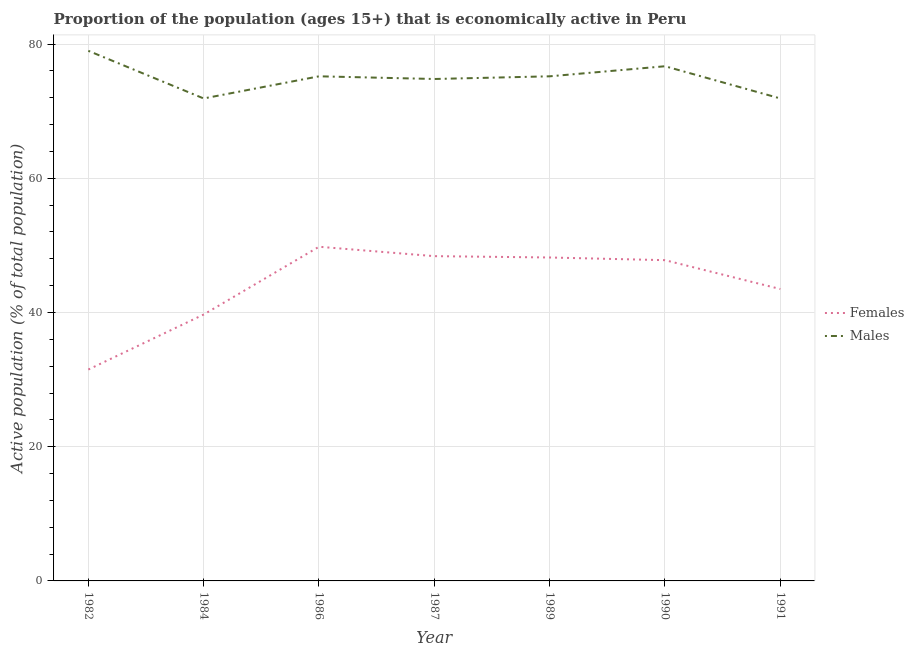How many different coloured lines are there?
Make the answer very short. 2. Is the number of lines equal to the number of legend labels?
Your answer should be very brief. Yes. What is the percentage of economically active male population in 1990?
Provide a short and direct response. 76.7. Across all years, what is the maximum percentage of economically active male population?
Offer a very short reply. 79. Across all years, what is the minimum percentage of economically active female population?
Keep it short and to the point. 31.5. In which year was the percentage of economically active male population minimum?
Your response must be concise. 1984. What is the total percentage of economically active male population in the graph?
Make the answer very short. 524.7. What is the difference between the percentage of economically active female population in 1982 and that in 1984?
Your answer should be very brief. -8.2. What is the difference between the percentage of economically active female population in 1990 and the percentage of economically active male population in 1984?
Offer a very short reply. -24.1. What is the average percentage of economically active female population per year?
Offer a terse response. 44.13. In the year 1987, what is the difference between the percentage of economically active female population and percentage of economically active male population?
Make the answer very short. -26.4. What is the ratio of the percentage of economically active female population in 1984 to that in 1990?
Give a very brief answer. 0.83. What is the difference between the highest and the second highest percentage of economically active male population?
Keep it short and to the point. 2.3. What is the difference between the highest and the lowest percentage of economically active male population?
Provide a short and direct response. 7.1. In how many years, is the percentage of economically active female population greater than the average percentage of economically active female population taken over all years?
Your response must be concise. 4. Is the percentage of economically active female population strictly greater than the percentage of economically active male population over the years?
Provide a succinct answer. No. How many years are there in the graph?
Your answer should be very brief. 7. Where does the legend appear in the graph?
Offer a terse response. Center right. How many legend labels are there?
Offer a very short reply. 2. What is the title of the graph?
Your answer should be compact. Proportion of the population (ages 15+) that is economically active in Peru. What is the label or title of the Y-axis?
Offer a terse response. Active population (% of total population). What is the Active population (% of total population) of Females in 1982?
Make the answer very short. 31.5. What is the Active population (% of total population) of Males in 1982?
Give a very brief answer. 79. What is the Active population (% of total population) of Females in 1984?
Provide a short and direct response. 39.7. What is the Active population (% of total population) in Males in 1984?
Make the answer very short. 71.9. What is the Active population (% of total population) in Females in 1986?
Your answer should be compact. 49.8. What is the Active population (% of total population) of Males in 1986?
Provide a succinct answer. 75.2. What is the Active population (% of total population) in Females in 1987?
Your answer should be very brief. 48.4. What is the Active population (% of total population) in Males in 1987?
Offer a terse response. 74.8. What is the Active population (% of total population) of Females in 1989?
Provide a succinct answer. 48.2. What is the Active population (% of total population) of Males in 1989?
Ensure brevity in your answer.  75.2. What is the Active population (% of total population) in Females in 1990?
Give a very brief answer. 47.8. What is the Active population (% of total population) of Males in 1990?
Make the answer very short. 76.7. What is the Active population (% of total population) of Females in 1991?
Provide a succinct answer. 43.5. What is the Active population (% of total population) in Males in 1991?
Your answer should be compact. 71.9. Across all years, what is the maximum Active population (% of total population) in Females?
Keep it short and to the point. 49.8. Across all years, what is the maximum Active population (% of total population) in Males?
Keep it short and to the point. 79. Across all years, what is the minimum Active population (% of total population) of Females?
Keep it short and to the point. 31.5. Across all years, what is the minimum Active population (% of total population) of Males?
Offer a terse response. 71.9. What is the total Active population (% of total population) of Females in the graph?
Give a very brief answer. 308.9. What is the total Active population (% of total population) of Males in the graph?
Provide a short and direct response. 524.7. What is the difference between the Active population (% of total population) in Females in 1982 and that in 1984?
Your response must be concise. -8.2. What is the difference between the Active population (% of total population) of Males in 1982 and that in 1984?
Your answer should be very brief. 7.1. What is the difference between the Active population (% of total population) of Females in 1982 and that in 1986?
Provide a succinct answer. -18.3. What is the difference between the Active population (% of total population) in Females in 1982 and that in 1987?
Provide a short and direct response. -16.9. What is the difference between the Active population (% of total population) of Males in 1982 and that in 1987?
Offer a terse response. 4.2. What is the difference between the Active population (% of total population) in Females in 1982 and that in 1989?
Offer a very short reply. -16.7. What is the difference between the Active population (% of total population) in Females in 1982 and that in 1990?
Offer a very short reply. -16.3. What is the difference between the Active population (% of total population) in Males in 1984 and that in 1986?
Ensure brevity in your answer.  -3.3. What is the difference between the Active population (% of total population) of Females in 1984 and that in 1987?
Make the answer very short. -8.7. What is the difference between the Active population (% of total population) in Females in 1984 and that in 1989?
Your answer should be very brief. -8.5. What is the difference between the Active population (% of total population) of Females in 1984 and that in 1990?
Ensure brevity in your answer.  -8.1. What is the difference between the Active population (% of total population) in Males in 1984 and that in 1990?
Provide a succinct answer. -4.8. What is the difference between the Active population (% of total population) of Females in 1984 and that in 1991?
Provide a succinct answer. -3.8. What is the difference between the Active population (% of total population) in Males in 1984 and that in 1991?
Keep it short and to the point. 0. What is the difference between the Active population (% of total population) in Males in 1986 and that in 1987?
Offer a very short reply. 0.4. What is the difference between the Active population (% of total population) in Females in 1986 and that in 1989?
Make the answer very short. 1.6. What is the difference between the Active population (% of total population) of Females in 1986 and that in 1990?
Ensure brevity in your answer.  2. What is the difference between the Active population (% of total population) in Females in 1986 and that in 1991?
Offer a terse response. 6.3. What is the difference between the Active population (% of total population) in Males in 1986 and that in 1991?
Your answer should be compact. 3.3. What is the difference between the Active population (% of total population) of Males in 1987 and that in 1989?
Make the answer very short. -0.4. What is the difference between the Active population (% of total population) in Females in 1987 and that in 1991?
Ensure brevity in your answer.  4.9. What is the difference between the Active population (% of total population) in Males in 1987 and that in 1991?
Give a very brief answer. 2.9. What is the difference between the Active population (% of total population) of Females in 1989 and that in 1990?
Ensure brevity in your answer.  0.4. What is the difference between the Active population (% of total population) in Females in 1989 and that in 1991?
Give a very brief answer. 4.7. What is the difference between the Active population (% of total population) of Females in 1982 and the Active population (% of total population) of Males in 1984?
Offer a very short reply. -40.4. What is the difference between the Active population (% of total population) of Females in 1982 and the Active population (% of total population) of Males in 1986?
Give a very brief answer. -43.7. What is the difference between the Active population (% of total population) of Females in 1982 and the Active population (% of total population) of Males in 1987?
Ensure brevity in your answer.  -43.3. What is the difference between the Active population (% of total population) of Females in 1982 and the Active population (% of total population) of Males in 1989?
Make the answer very short. -43.7. What is the difference between the Active population (% of total population) in Females in 1982 and the Active population (% of total population) in Males in 1990?
Offer a terse response. -45.2. What is the difference between the Active population (% of total population) of Females in 1982 and the Active population (% of total population) of Males in 1991?
Make the answer very short. -40.4. What is the difference between the Active population (% of total population) of Females in 1984 and the Active population (% of total population) of Males in 1986?
Ensure brevity in your answer.  -35.5. What is the difference between the Active population (% of total population) in Females in 1984 and the Active population (% of total population) in Males in 1987?
Your response must be concise. -35.1. What is the difference between the Active population (% of total population) of Females in 1984 and the Active population (% of total population) of Males in 1989?
Your response must be concise. -35.5. What is the difference between the Active population (% of total population) in Females in 1984 and the Active population (% of total population) in Males in 1990?
Offer a terse response. -37. What is the difference between the Active population (% of total population) of Females in 1984 and the Active population (% of total population) of Males in 1991?
Give a very brief answer. -32.2. What is the difference between the Active population (% of total population) in Females in 1986 and the Active population (% of total population) in Males in 1989?
Give a very brief answer. -25.4. What is the difference between the Active population (% of total population) in Females in 1986 and the Active population (% of total population) in Males in 1990?
Ensure brevity in your answer.  -26.9. What is the difference between the Active population (% of total population) in Females in 1986 and the Active population (% of total population) in Males in 1991?
Offer a terse response. -22.1. What is the difference between the Active population (% of total population) in Females in 1987 and the Active population (% of total population) in Males in 1989?
Offer a terse response. -26.8. What is the difference between the Active population (% of total population) of Females in 1987 and the Active population (% of total population) of Males in 1990?
Keep it short and to the point. -28.3. What is the difference between the Active population (% of total population) in Females in 1987 and the Active population (% of total population) in Males in 1991?
Provide a short and direct response. -23.5. What is the difference between the Active population (% of total population) of Females in 1989 and the Active population (% of total population) of Males in 1990?
Your answer should be compact. -28.5. What is the difference between the Active population (% of total population) in Females in 1989 and the Active population (% of total population) in Males in 1991?
Offer a terse response. -23.7. What is the difference between the Active population (% of total population) of Females in 1990 and the Active population (% of total population) of Males in 1991?
Provide a short and direct response. -24.1. What is the average Active population (% of total population) in Females per year?
Give a very brief answer. 44.13. What is the average Active population (% of total population) of Males per year?
Your answer should be compact. 74.96. In the year 1982, what is the difference between the Active population (% of total population) in Females and Active population (% of total population) in Males?
Provide a short and direct response. -47.5. In the year 1984, what is the difference between the Active population (% of total population) of Females and Active population (% of total population) of Males?
Provide a succinct answer. -32.2. In the year 1986, what is the difference between the Active population (% of total population) of Females and Active population (% of total population) of Males?
Make the answer very short. -25.4. In the year 1987, what is the difference between the Active population (% of total population) in Females and Active population (% of total population) in Males?
Offer a very short reply. -26.4. In the year 1989, what is the difference between the Active population (% of total population) in Females and Active population (% of total population) in Males?
Provide a short and direct response. -27. In the year 1990, what is the difference between the Active population (% of total population) of Females and Active population (% of total population) of Males?
Your answer should be compact. -28.9. In the year 1991, what is the difference between the Active population (% of total population) in Females and Active population (% of total population) in Males?
Give a very brief answer. -28.4. What is the ratio of the Active population (% of total population) in Females in 1982 to that in 1984?
Ensure brevity in your answer.  0.79. What is the ratio of the Active population (% of total population) of Males in 1982 to that in 1984?
Offer a terse response. 1.1. What is the ratio of the Active population (% of total population) in Females in 1982 to that in 1986?
Keep it short and to the point. 0.63. What is the ratio of the Active population (% of total population) in Males in 1982 to that in 1986?
Offer a terse response. 1.05. What is the ratio of the Active population (% of total population) in Females in 1982 to that in 1987?
Your response must be concise. 0.65. What is the ratio of the Active population (% of total population) in Males in 1982 to that in 1987?
Ensure brevity in your answer.  1.06. What is the ratio of the Active population (% of total population) of Females in 1982 to that in 1989?
Offer a very short reply. 0.65. What is the ratio of the Active population (% of total population) of Males in 1982 to that in 1989?
Ensure brevity in your answer.  1.05. What is the ratio of the Active population (% of total population) of Females in 1982 to that in 1990?
Your answer should be very brief. 0.66. What is the ratio of the Active population (% of total population) of Males in 1982 to that in 1990?
Make the answer very short. 1.03. What is the ratio of the Active population (% of total population) in Females in 1982 to that in 1991?
Give a very brief answer. 0.72. What is the ratio of the Active population (% of total population) in Males in 1982 to that in 1991?
Make the answer very short. 1.1. What is the ratio of the Active population (% of total population) of Females in 1984 to that in 1986?
Keep it short and to the point. 0.8. What is the ratio of the Active population (% of total population) of Males in 1984 to that in 1986?
Give a very brief answer. 0.96. What is the ratio of the Active population (% of total population) in Females in 1984 to that in 1987?
Ensure brevity in your answer.  0.82. What is the ratio of the Active population (% of total population) of Males in 1984 to that in 1987?
Offer a terse response. 0.96. What is the ratio of the Active population (% of total population) of Females in 1984 to that in 1989?
Make the answer very short. 0.82. What is the ratio of the Active population (% of total population) in Males in 1984 to that in 1989?
Your response must be concise. 0.96. What is the ratio of the Active population (% of total population) in Females in 1984 to that in 1990?
Ensure brevity in your answer.  0.83. What is the ratio of the Active population (% of total population) in Males in 1984 to that in 1990?
Ensure brevity in your answer.  0.94. What is the ratio of the Active population (% of total population) of Females in 1984 to that in 1991?
Keep it short and to the point. 0.91. What is the ratio of the Active population (% of total population) of Females in 1986 to that in 1987?
Keep it short and to the point. 1.03. What is the ratio of the Active population (% of total population) of Males in 1986 to that in 1987?
Make the answer very short. 1.01. What is the ratio of the Active population (% of total population) of Females in 1986 to that in 1989?
Offer a very short reply. 1.03. What is the ratio of the Active population (% of total population) of Males in 1986 to that in 1989?
Provide a succinct answer. 1. What is the ratio of the Active population (% of total population) of Females in 1986 to that in 1990?
Ensure brevity in your answer.  1.04. What is the ratio of the Active population (% of total population) of Males in 1986 to that in 1990?
Make the answer very short. 0.98. What is the ratio of the Active population (% of total population) in Females in 1986 to that in 1991?
Offer a very short reply. 1.14. What is the ratio of the Active population (% of total population) in Males in 1986 to that in 1991?
Offer a very short reply. 1.05. What is the ratio of the Active population (% of total population) of Males in 1987 to that in 1989?
Provide a succinct answer. 0.99. What is the ratio of the Active population (% of total population) in Females in 1987 to that in 1990?
Make the answer very short. 1.01. What is the ratio of the Active population (% of total population) in Males in 1987 to that in 1990?
Ensure brevity in your answer.  0.98. What is the ratio of the Active population (% of total population) in Females in 1987 to that in 1991?
Give a very brief answer. 1.11. What is the ratio of the Active population (% of total population) in Males in 1987 to that in 1991?
Give a very brief answer. 1.04. What is the ratio of the Active population (% of total population) in Females in 1989 to that in 1990?
Provide a succinct answer. 1.01. What is the ratio of the Active population (% of total population) in Males in 1989 to that in 1990?
Keep it short and to the point. 0.98. What is the ratio of the Active population (% of total population) of Females in 1989 to that in 1991?
Provide a succinct answer. 1.11. What is the ratio of the Active population (% of total population) of Males in 1989 to that in 1991?
Your answer should be very brief. 1.05. What is the ratio of the Active population (% of total population) of Females in 1990 to that in 1991?
Give a very brief answer. 1.1. What is the ratio of the Active population (% of total population) in Males in 1990 to that in 1991?
Provide a succinct answer. 1.07. What is the difference between the highest and the lowest Active population (% of total population) of Males?
Your answer should be very brief. 7.1. 